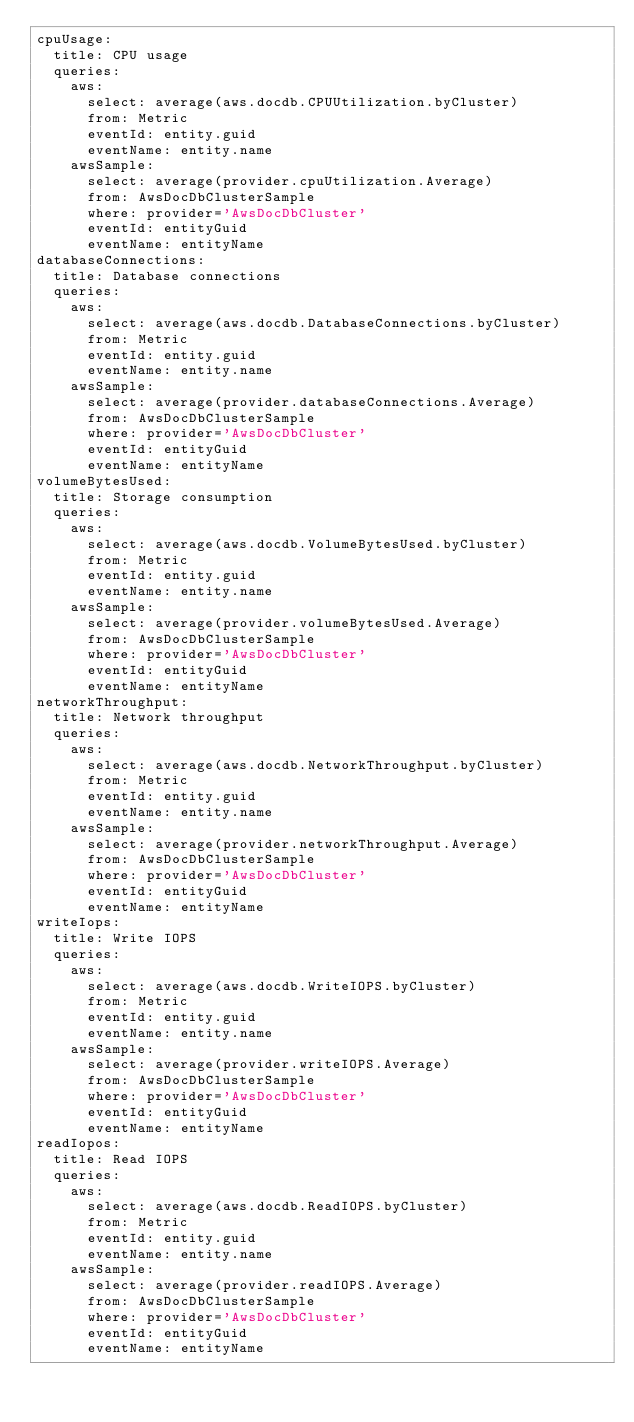<code> <loc_0><loc_0><loc_500><loc_500><_YAML_>cpuUsage:
  title: CPU usage
  queries:
    aws:
      select: average(aws.docdb.CPUUtilization.byCluster)
      from: Metric
      eventId: entity.guid
      eventName: entity.name
    awsSample:
      select: average(provider.cpuUtilization.Average)
      from: AwsDocDbClusterSample
      where: provider='AwsDocDbCluster'
      eventId: entityGuid
      eventName: entityName
databaseConnections:
  title: Database connections
  queries:
    aws:
      select: average(aws.docdb.DatabaseConnections.byCluster)
      from: Metric
      eventId: entity.guid
      eventName: entity.name
    awsSample:
      select: average(provider.databaseConnections.Average)
      from: AwsDocDbClusterSample
      where: provider='AwsDocDbCluster'
      eventId: entityGuid
      eventName: entityName
volumeBytesUsed:
  title: Storage consumption
  queries:
    aws:
      select: average(aws.docdb.VolumeBytesUsed.byCluster)
      from: Metric
      eventId: entity.guid
      eventName: entity.name
    awsSample:
      select: average(provider.volumeBytesUsed.Average)
      from: AwsDocDbClusterSample
      where: provider='AwsDocDbCluster'
      eventId: entityGuid
      eventName: entityName
networkThroughput:
  title: Network throughput
  queries:
    aws:
      select: average(aws.docdb.NetworkThroughput.byCluster)
      from: Metric
      eventId: entity.guid
      eventName: entity.name
    awsSample:
      select: average(provider.networkThroughput.Average)
      from: AwsDocDbClusterSample
      where: provider='AwsDocDbCluster'
      eventId: entityGuid
      eventName: entityName
writeIops:
  title: Write IOPS
  queries:
    aws:
      select: average(aws.docdb.WriteIOPS.byCluster)
      from: Metric
      eventId: entity.guid
      eventName: entity.name
    awsSample:
      select: average(provider.writeIOPS.Average)
      from: AwsDocDbClusterSample
      where: provider='AwsDocDbCluster'
      eventId: entityGuid
      eventName: entityName
readIopos:
  title: Read IOPS
  queries:
    aws:
      select: average(aws.docdb.ReadIOPS.byCluster)
      from: Metric
      eventId: entity.guid
      eventName: entity.name
    awsSample:
      select: average(provider.readIOPS.Average)
      from: AwsDocDbClusterSample
      where: provider='AwsDocDbCluster'
      eventId: entityGuid
      eventName: entityName
</code> 